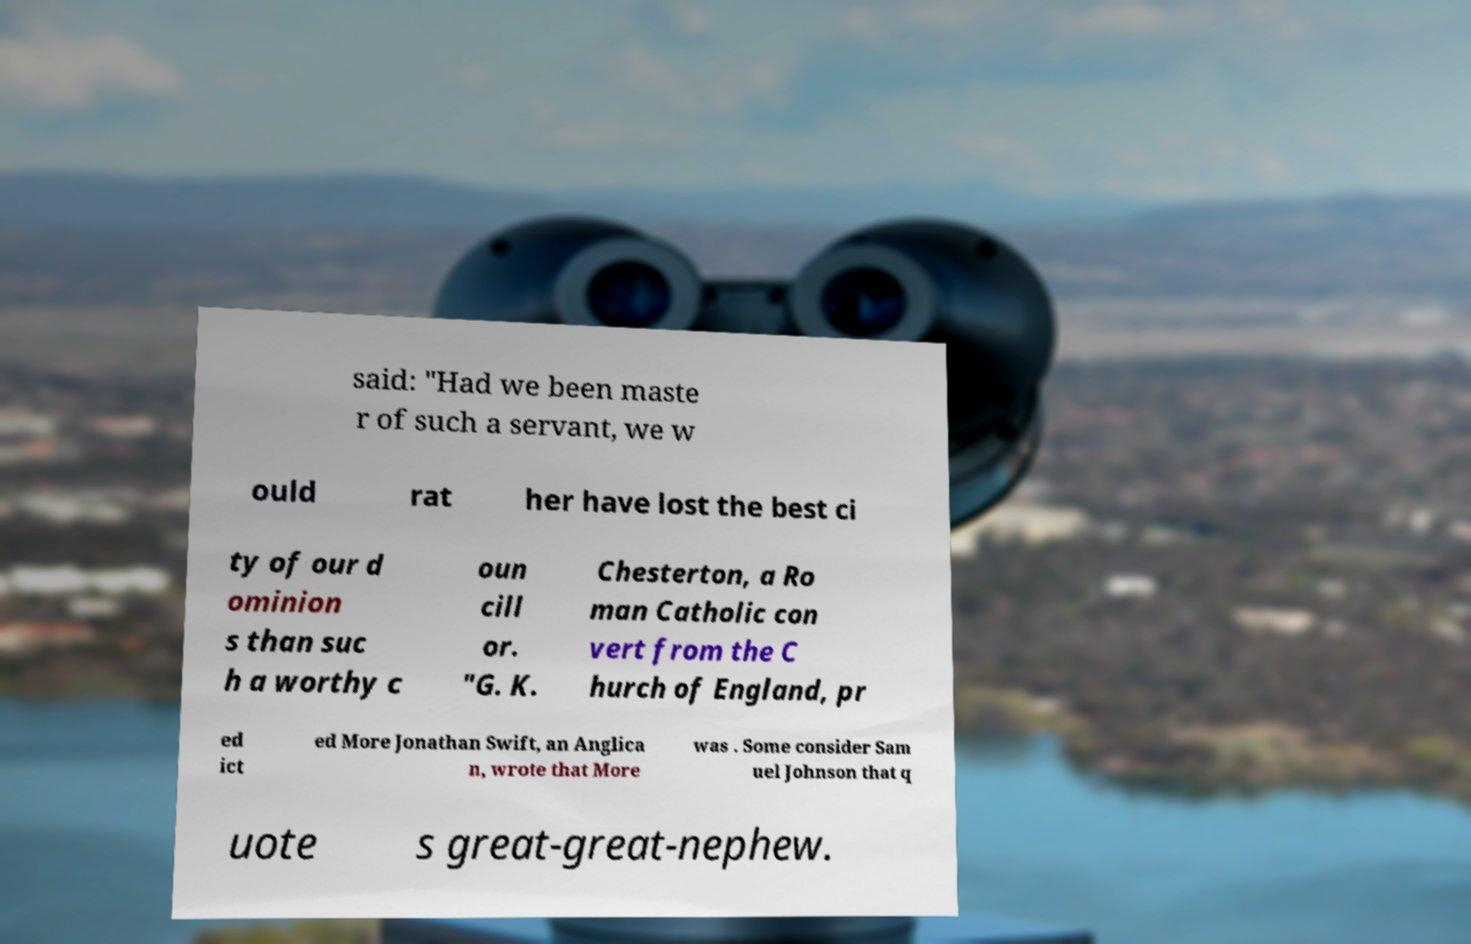Could you extract and type out the text from this image? said: "Had we been maste r of such a servant, we w ould rat her have lost the best ci ty of our d ominion s than suc h a worthy c oun cill or. "G. K. Chesterton, a Ro man Catholic con vert from the C hurch of England, pr ed ict ed More Jonathan Swift, an Anglica n, wrote that More was . Some consider Sam uel Johnson that q uote s great-great-nephew. 